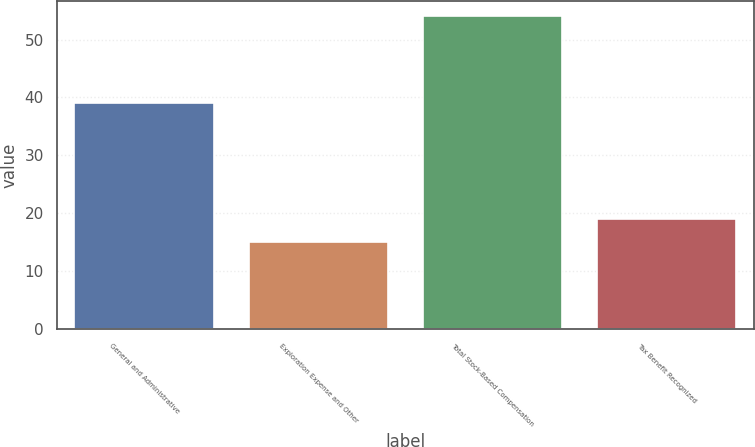Convert chart. <chart><loc_0><loc_0><loc_500><loc_500><bar_chart><fcel>General and Administrative<fcel>Exploration Expense and Other<fcel>Total Stock-Based Compensation<fcel>Tax Benefit Recognized<nl><fcel>39<fcel>15<fcel>54<fcel>19<nl></chart> 